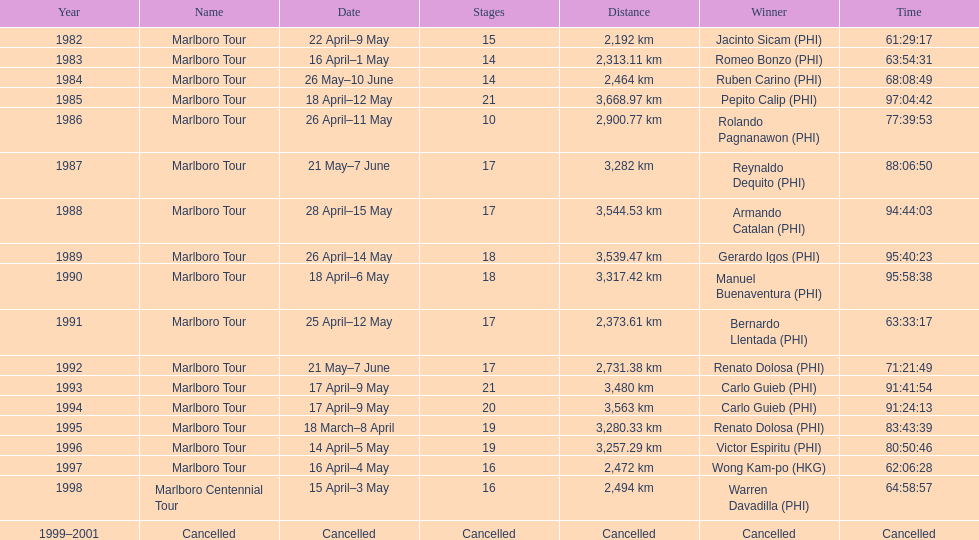Each year, what was the distance traveled by the marlboro tour? 2,192 km, 2,313.11 km, 2,464 km, 3,668.97 km, 2,900.77 km, 3,282 km, 3,544.53 km, 3,539.47 km, 3,317.42 km, 2,373.61 km, 2,731.38 km, 3,480 km, 3,563 km, 3,280.33 km, 3,257.29 km, 2,472 km, 2,494 km, Cancelled. When did they travel the greatest distance? 1985. How much distance was covered in that year? 3,668.97 km. 